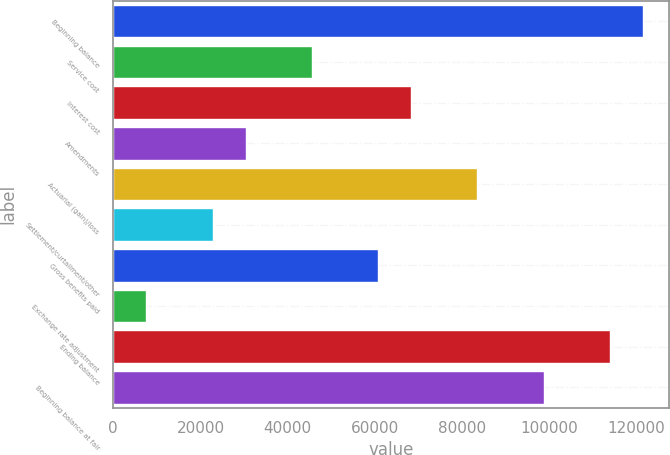<chart> <loc_0><loc_0><loc_500><loc_500><bar_chart><fcel>Beginning balance<fcel>Service cost<fcel>Interest cost<fcel>Amendments<fcel>Actuarial (gain)/loss<fcel>Settlement/curtailment/other<fcel>Gross benefits paid<fcel>Exchange rate adjustment<fcel>Ending balance<fcel>Beginning balance at fair<nl><fcel>121427<fcel>45540.2<fcel>68306.3<fcel>30362.8<fcel>83483.7<fcel>22774.1<fcel>60717.6<fcel>7596.7<fcel>113838<fcel>98661.1<nl></chart> 